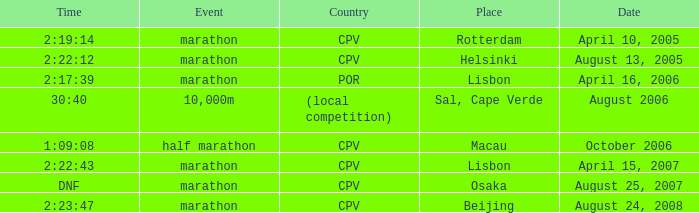What is the Country of the Half Marathon Event? CPV. 